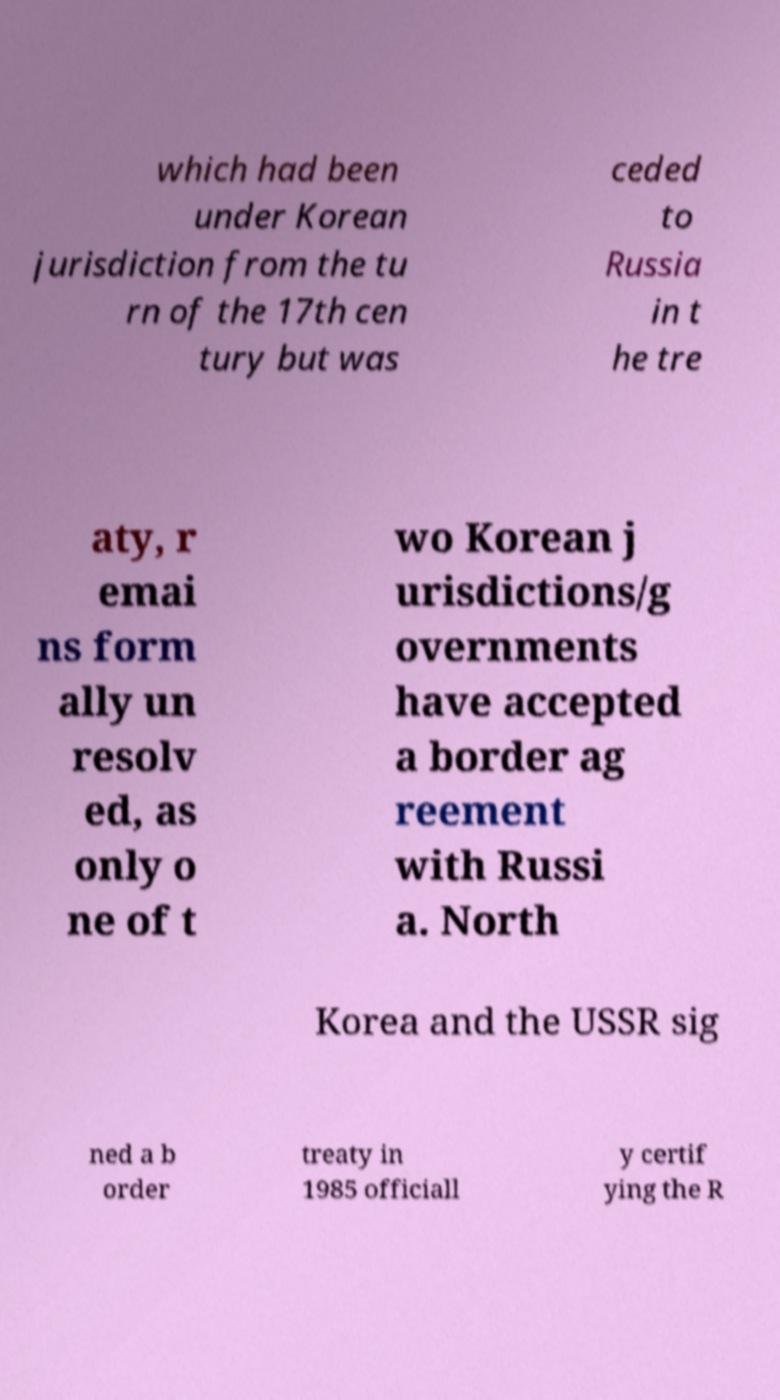Please read and relay the text visible in this image. What does it say? which had been under Korean jurisdiction from the tu rn of the 17th cen tury but was ceded to Russia in t he tre aty, r emai ns form ally un resolv ed, as only o ne of t wo Korean j urisdictions/g overnments have accepted a border ag reement with Russi a. North Korea and the USSR sig ned a b order treaty in 1985 officiall y certif ying the R 